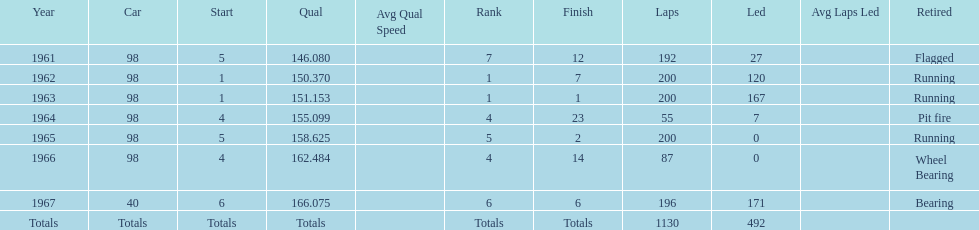Number of times to finish the races running. 3. 